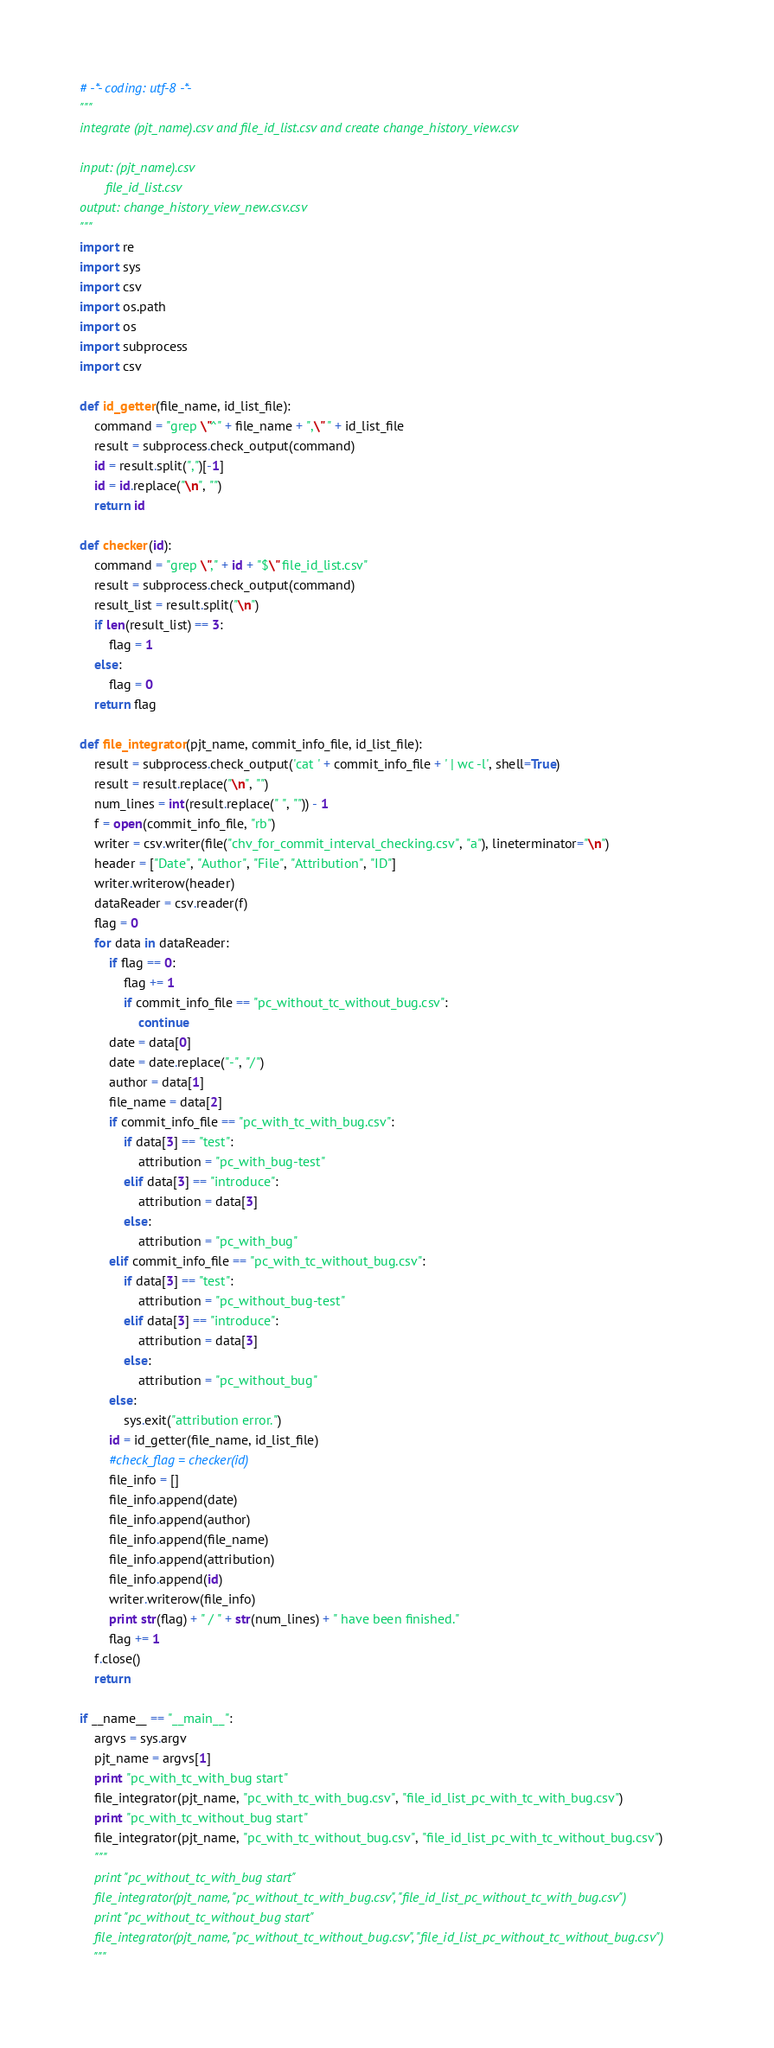Convert code to text. <code><loc_0><loc_0><loc_500><loc_500><_Python_># -*- coding: utf-8 -*-
"""
integrate (pjt_name).csv and file_id_list.csv and create change_history_view.csv

input: (pjt_name).csv
	   file_id_list.csv
output: change_history_view_new.csv.csv
"""
import re
import sys
import csv
import os.path
import os
import subprocess
import csv

def id_getter(file_name, id_list_file):
	command = "grep \"^" + file_name + ",\" " + id_list_file
	result = subprocess.check_output(command)
	id = result.split(",")[-1]
	id = id.replace("\n", "")
	return id

def checker(id):
	command = "grep \"," + id + "$\" file_id_list.csv"
	result = subprocess.check_output(command)
	result_list = result.split("\n")
	if len(result_list) == 3:
		flag = 1
	else:
		flag = 0
	return flag

def file_integrator(pjt_name, commit_info_file, id_list_file):
	result = subprocess.check_output('cat ' + commit_info_file + ' | wc -l', shell=True)
	result = result.replace("\n", "")
	num_lines = int(result.replace(" ", "")) - 1
	f = open(commit_info_file, "rb")
	writer = csv.writer(file("chv_for_commit_interval_checking.csv", "a"), lineterminator="\n")
	header = ["Date", "Author", "File", "Attribution", "ID"]
	writer.writerow(header)
	dataReader = csv.reader(f)
	flag = 0
	for data in dataReader:
		if flag == 0:
			flag += 1
			if commit_info_file == "pc_without_tc_without_bug.csv":
				continue
		date = data[0]
		date = date.replace("-", "/")
		author = data[1]
		file_name = data[2]
		if commit_info_file == "pc_with_tc_with_bug.csv":
			if data[3] == "test":
				attribution = "pc_with_bug-test"
			elif data[3] == "introduce":
				attribution = data[3]
			else:
				attribution = "pc_with_bug"
		elif commit_info_file == "pc_with_tc_without_bug.csv":
			if data[3] == "test":
				attribution = "pc_without_bug-test"
			elif data[3] == "introduce":
				attribution = data[3]
			else:
				attribution = "pc_without_bug"
		else:
			sys.exit("attribution error.")
		id = id_getter(file_name, id_list_file)
		#check_flag = checker(id)
		file_info = []
		file_info.append(date)
		file_info.append(author)
		file_info.append(file_name)
		file_info.append(attribution)
		file_info.append(id)
		writer.writerow(file_info)
		print str(flag) + " / " + str(num_lines) + " have been finished."
		flag += 1
	f.close()
	return

if __name__ == "__main__":
	argvs = sys.argv
	pjt_name = argvs[1]
	print "pc_with_tc_with_bug start"
	file_integrator(pjt_name, "pc_with_tc_with_bug.csv", "file_id_list_pc_with_tc_with_bug.csv")
	print "pc_with_tc_without_bug start"
	file_integrator(pjt_name, "pc_with_tc_without_bug.csv", "file_id_list_pc_with_tc_without_bug.csv")
	"""
	print "pc_without_tc_with_bug start"
	file_integrator(pjt_name, "pc_without_tc_with_bug.csv", "file_id_list_pc_without_tc_with_bug.csv")
	print "pc_without_tc_without_bug start"
	file_integrator(pjt_name, "pc_without_tc_without_bug.csv", "file_id_list_pc_without_tc_without_bug.csv")
	"""
</code> 